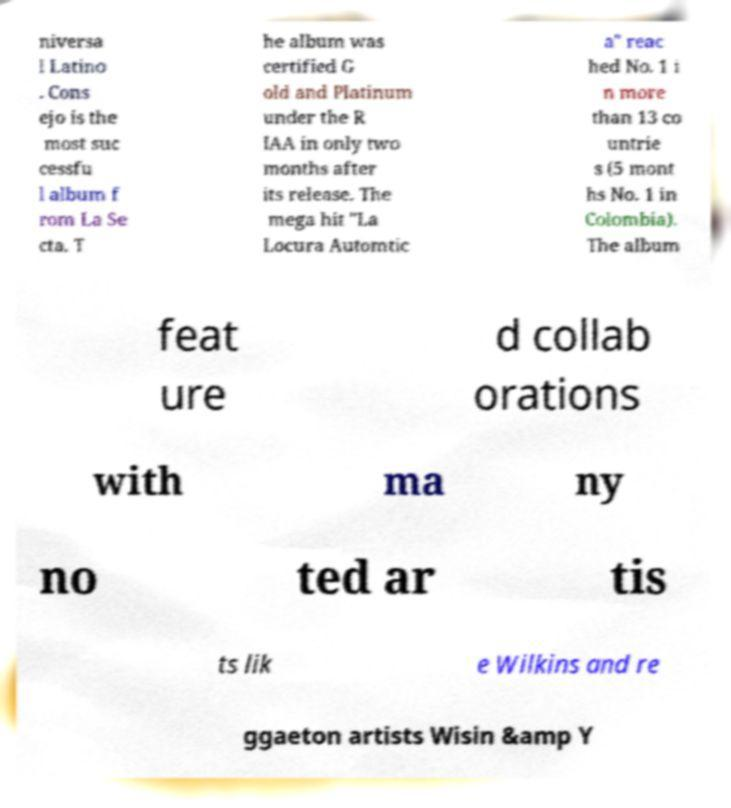Please identify and transcribe the text found in this image. niversa l Latino . Cons ejo is the most suc cessfu l album f rom La Se cta. T he album was certified G old and Platinum under the R IAA in only two months after its release. The mega hit "La Locura Automtic a" reac hed No. 1 i n more than 13 co untrie s (5 mont hs No. 1 in Colombia). The album feat ure d collab orations with ma ny no ted ar tis ts lik e Wilkins and re ggaeton artists Wisin &amp Y 